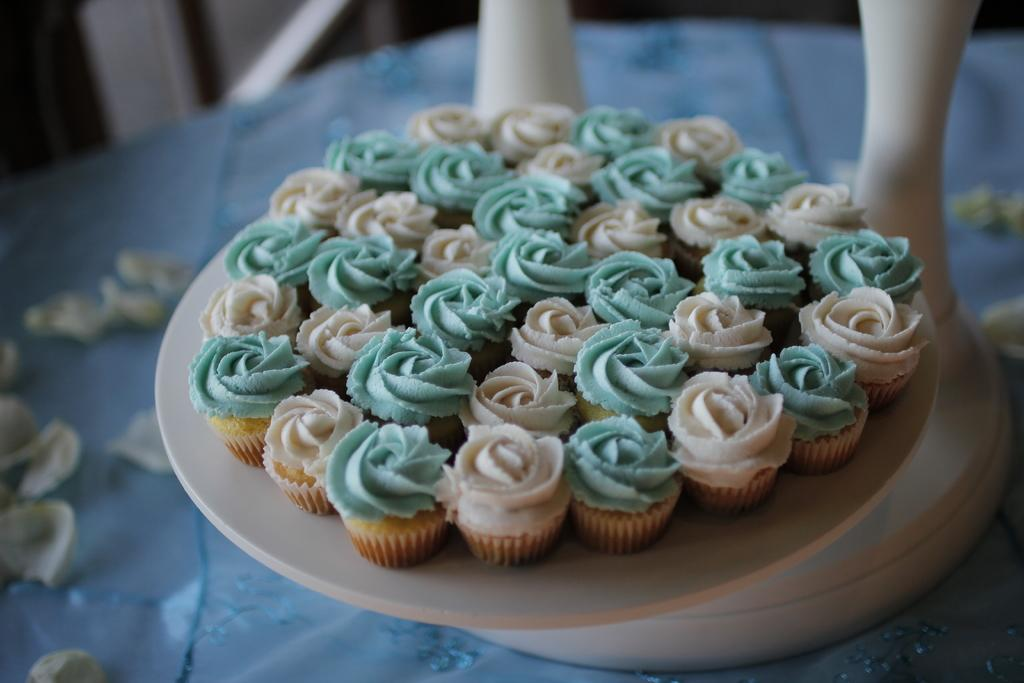What type of food is on the plate in the image? There are cupcakes on a plate in the image. Can you describe anything visible in the background of the image? Unfortunately, the provided facts do not give any specific details about the objects visible in the background of the image. What type of behavior can be observed from the sponge in the image? There is no sponge present in the image, so it is not possible to determine any behavior associated with it. 